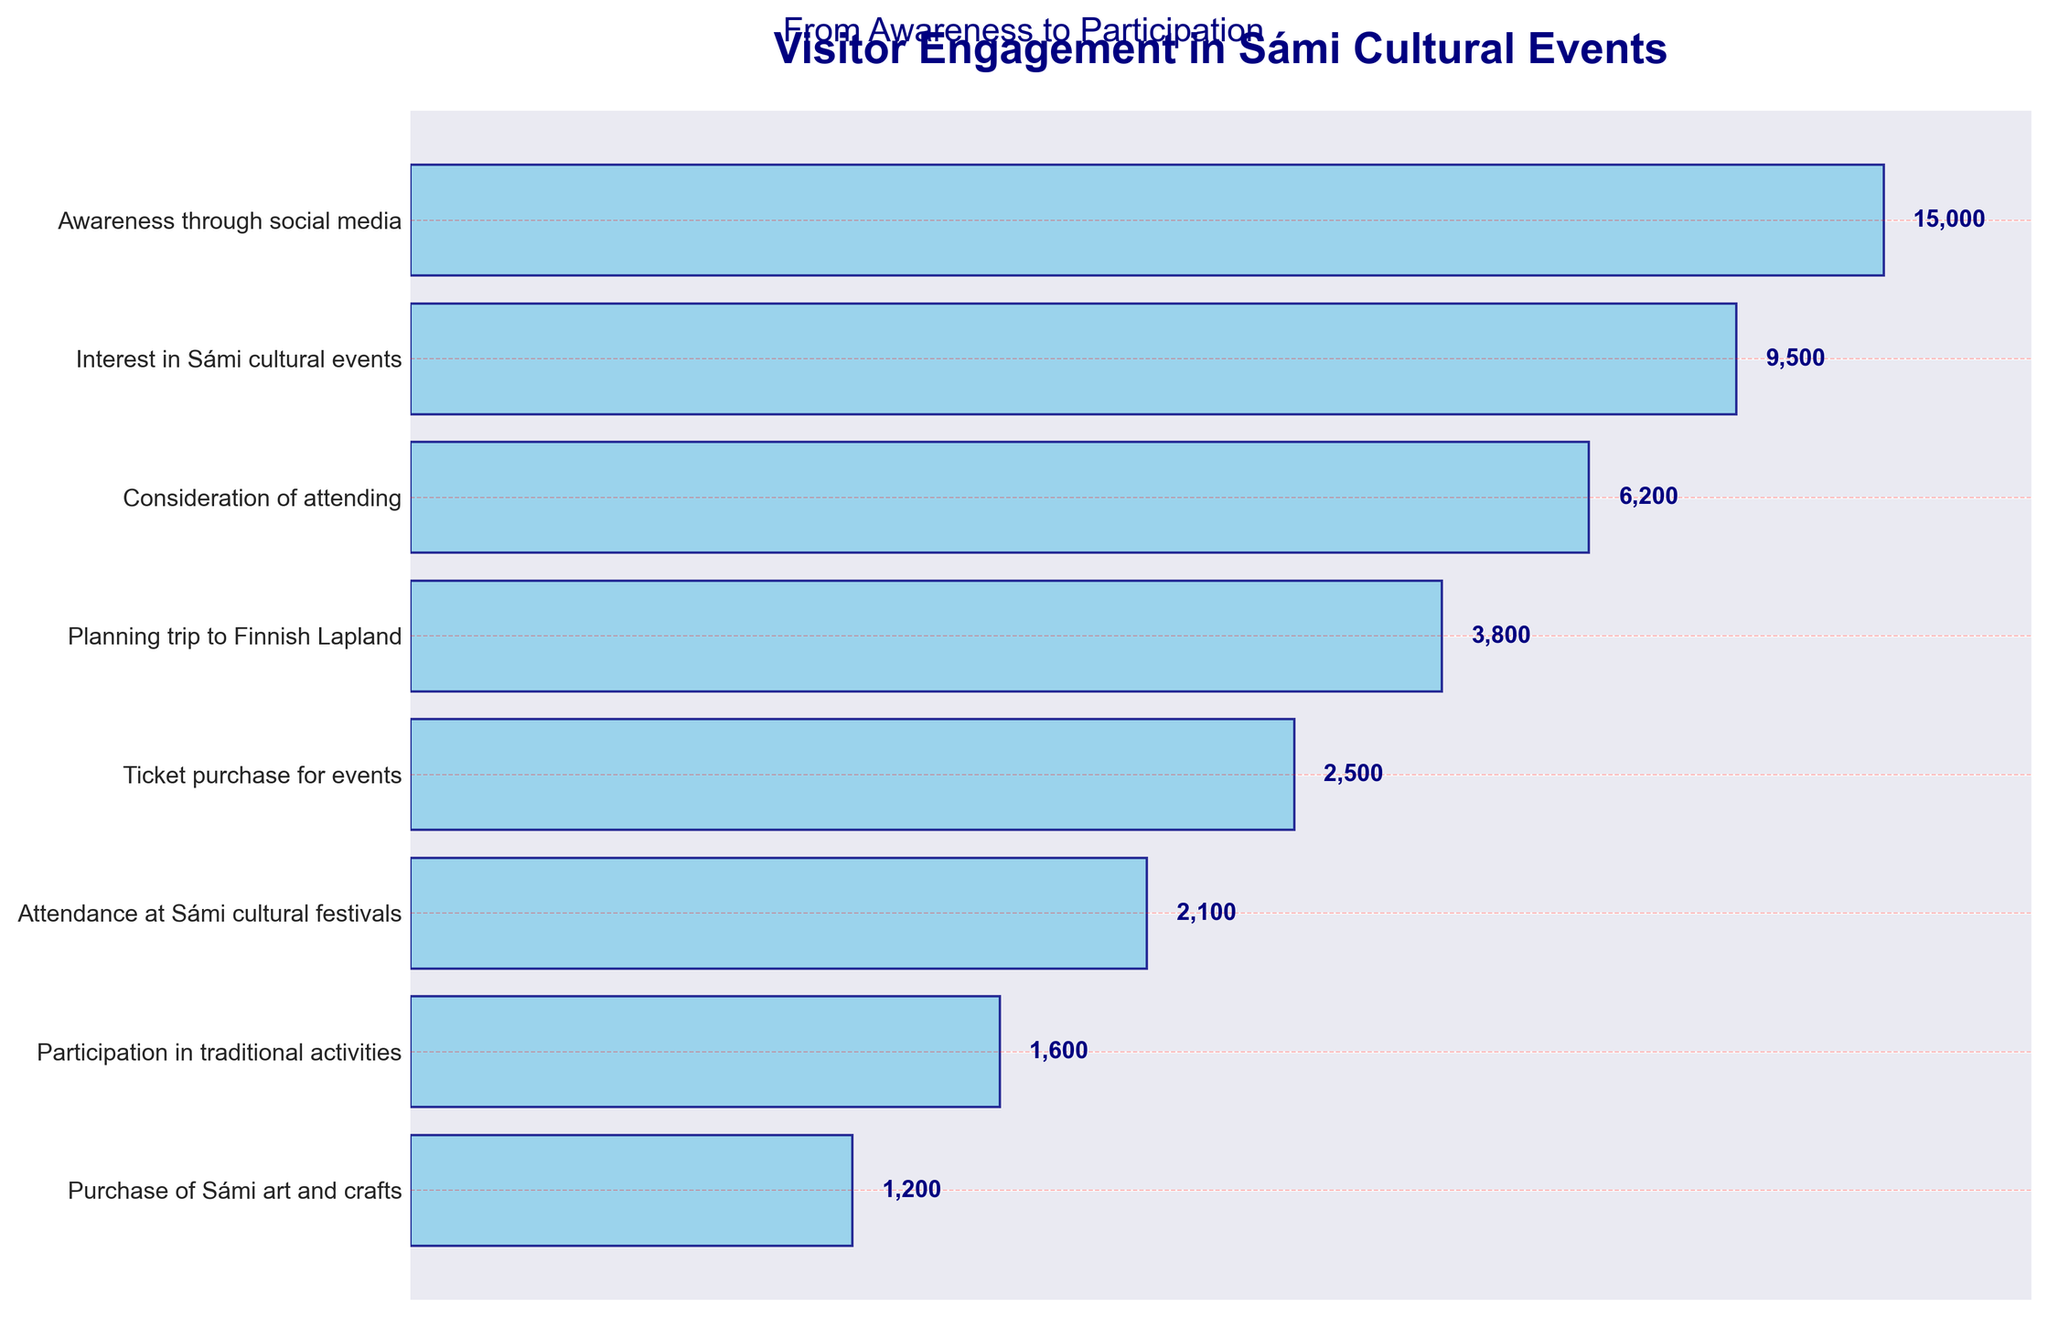What's the title of the chart? The title of the chart is usually found at the top of the figure. Here, it is seen as a large, bold text.
Answer: Visitor Engagement in Sámi Cultural Events How many stages are shown in the funnel chart? The number of stages corresponds to the number of horizontal bars in the chart. By counting them, we see eight stages.
Answer: 8 Which stage shows the highest number of visitors? Identify the stage with the highest visitor number. The first stage, "Awareness through social media," has 15,000 visitors.
Answer: Awareness through social media How many visitors ultimately participate in traditional activities? Check the visitor number next to the "Participation in traditional activities" stage. It shows 1,600 visitors.
Answer: 1,600 What is the percentage drop from "Awareness through social media" to "Interest in Sámi cultural events"? Calculate the percentage drop: \[\left(\frac{15000 - 9500}{15000}\right) \times 100 = 36.7\%\]
Answer: 36.7% What is the difference in visitor numbers between "Planning trip to Finnish Lapland" and "Attendance at Sámi cultural festivals"? Subtract the visitor number for "Attendance at Sámi cultural festivals" from "Planning trip to Finnish Lapland": 3800 - 2100 = 1700
Answer: 1,700 Which stage has the smallest number of visitors? Find the stage with the lowest number. "Purchase of Sámi art and crafts" has the fewest visitors with 1,200.
Answer: Purchase of Sámi art and crafts By how much does the number of visitors decrease from "Ticket purchase for events" to "Participation in traditional activities"? Subtract the visitor number for "Participation in traditional activities" from "Ticket purchase for events": 2500 - 1600 = 900
Answer: 900 Which stage comes right before "Purchase of Sámi art and crafts"? Identify the stage immediately preceding the final listed stage. "Participation in traditional activities" is right before "Purchase of Sámi art and crafts."
Answer: Participation in traditional activities The funnel chart shows a consistent engagement drop. By how many visitors does each stage differ, on average, from the previous one? The total drop in visitors from the start to the end is 15,000 - 1,200 = 13,800. Divide this by the number of stages minus one (8 - 1 = 7): 13,800 / 7 ≈ 1,971
Answer: 1,971 